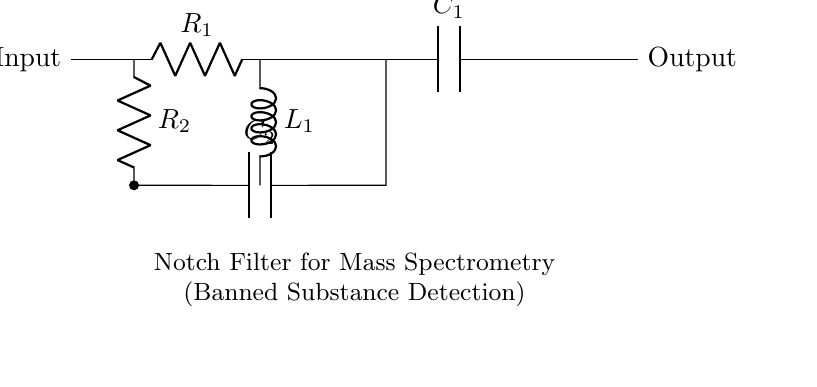What is the primary function of this circuit? This circuit is designed to reject specific frequencies, making it a notch filter. The term "notch" indicates its purpose of creating a dip in the frequency response at a particular frequency, which is applicable in mass spectrometry for detecting banned substances by filtering out unwanted noise.
Answer: notch filter What component is used to achieve frequency rejection? The frequency rejection is primarily achieved by the combination of the resistor and capacitor in parallel (R2 and C2), along with the inductor (L1). This combination creates a resonant circuit that reduces amplitude at the specified notch frequency.
Answer: R2 and C2 How many resistors are in the circuit? The circuit contains two resistors, R1 and R2, each serving different functions in filtering and maintaining stability in the signal path.
Answer: two What are the labels for the input and output of the circuit? The labels for the input and output are indicated as 'Input' on the left side and 'Output' on the right side of the circuit, which signifies where the signal enters and exits the circuit.
Answer: Input, Output Which component connects directly to the inductor? The component that connects directly to the inductor (L1) is the resistor R2, which is placed in parallel with capacitor C2. This placement is essential for defining the notch frequency characteristics.
Answer: R2 What is situated at the bottom of the circuit diagram? At the bottom of the circuit diagram, there is a note indicating that this is a Notch Filter for Mass Spectrometry, specifically for banned substance detection, providing context for the circuit's application.
Answer: Notch Filter for Mass Spectrometry 